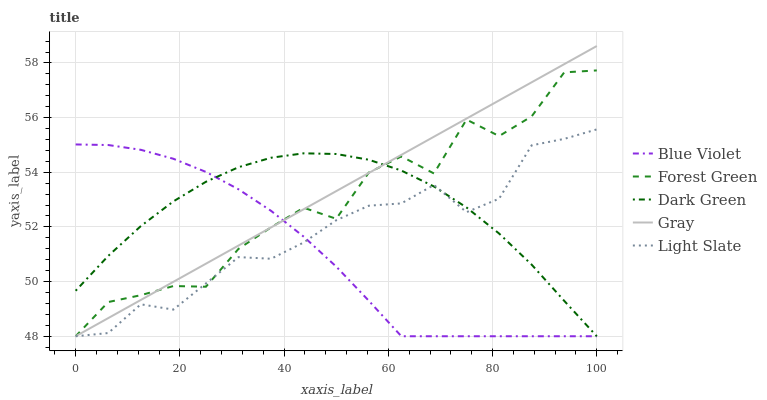Does Blue Violet have the minimum area under the curve?
Answer yes or no. Yes. Does Gray have the maximum area under the curve?
Answer yes or no. Yes. Does Forest Green have the minimum area under the curve?
Answer yes or no. No. Does Forest Green have the maximum area under the curve?
Answer yes or no. No. Is Gray the smoothest?
Answer yes or no. Yes. Is Forest Green the roughest?
Answer yes or no. Yes. Is Forest Green the smoothest?
Answer yes or no. No. Is Gray the roughest?
Answer yes or no. No. Does Light Slate have the lowest value?
Answer yes or no. Yes. Does Gray have the highest value?
Answer yes or no. Yes. Does Forest Green have the highest value?
Answer yes or no. No. Does Light Slate intersect Blue Violet?
Answer yes or no. Yes. Is Light Slate less than Blue Violet?
Answer yes or no. No. Is Light Slate greater than Blue Violet?
Answer yes or no. No. 